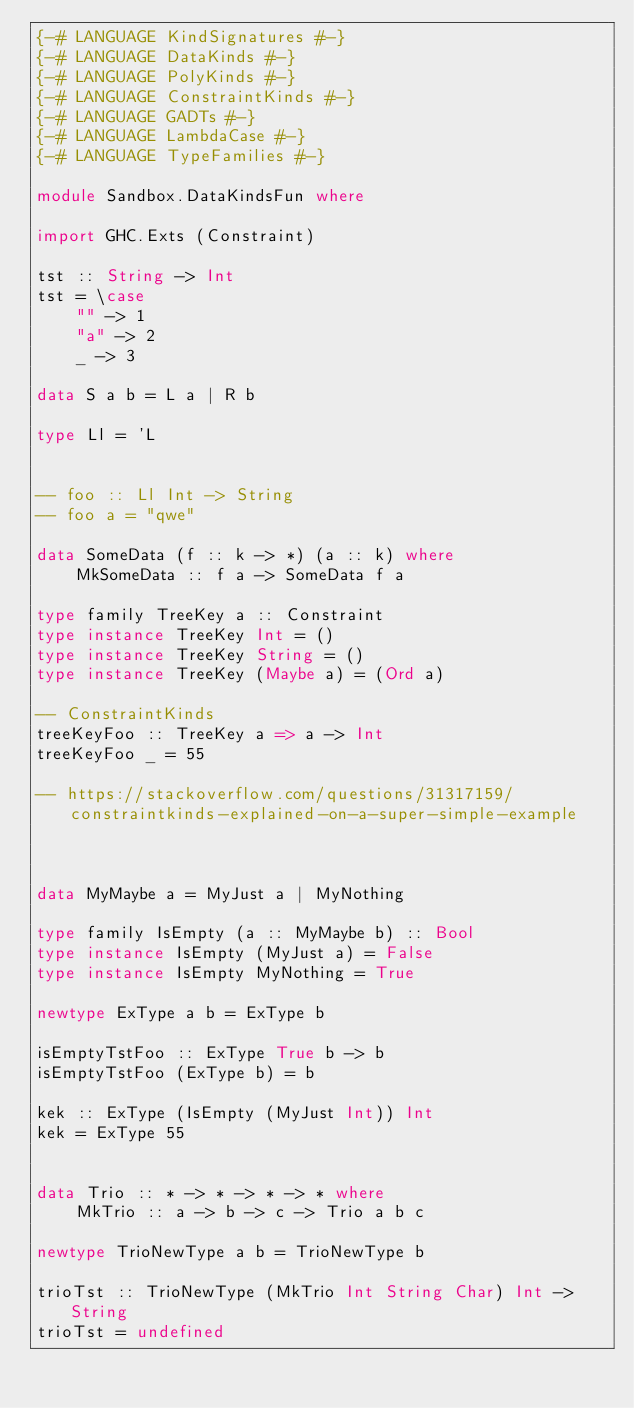<code> <loc_0><loc_0><loc_500><loc_500><_Haskell_>{-# LANGUAGE KindSignatures #-}
{-# LANGUAGE DataKinds #-}
{-# LANGUAGE PolyKinds #-}
{-# LANGUAGE ConstraintKinds #-}
{-# LANGUAGE GADTs #-}
{-# LANGUAGE LambdaCase #-}
{-# LANGUAGE TypeFamilies #-}

module Sandbox.DataKindsFun where

import GHC.Exts (Constraint)

tst :: String -> Int
tst = \case 
    "" -> 1
    "a" -> 2
    _ -> 3

data S a b = L a | R b

type Ll = 'L


-- foo :: Ll Int -> String
-- foo a = "qwe"

data SomeData (f :: k -> *) (a :: k) where 
    MkSomeData :: f a -> SomeData f a

type family TreeKey a :: Constraint
type instance TreeKey Int = ()
type instance TreeKey String = ()
type instance TreeKey (Maybe a) = (Ord a)

-- ConstraintKinds
treeKeyFoo :: TreeKey a => a -> Int
treeKeyFoo _ = 55

-- https://stackoverflow.com/questions/31317159/constraintkinds-explained-on-a-super-simple-example



data MyMaybe a = MyJust a | MyNothing

type family IsEmpty (a :: MyMaybe b) :: Bool
type instance IsEmpty (MyJust a) = False
type instance IsEmpty MyNothing = True

newtype ExType a b = ExType b

isEmptyTstFoo :: ExType True b -> b
isEmptyTstFoo (ExType b) = b

kek :: ExType (IsEmpty (MyJust Int)) Int 
kek = ExType 55


data Trio :: * -> * -> * -> * where 
    MkTrio :: a -> b -> c -> Trio a b c

newtype TrioNewType a b = TrioNewType b

trioTst :: TrioNewType (MkTrio Int String Char) Int -> String
trioTst = undefined</code> 